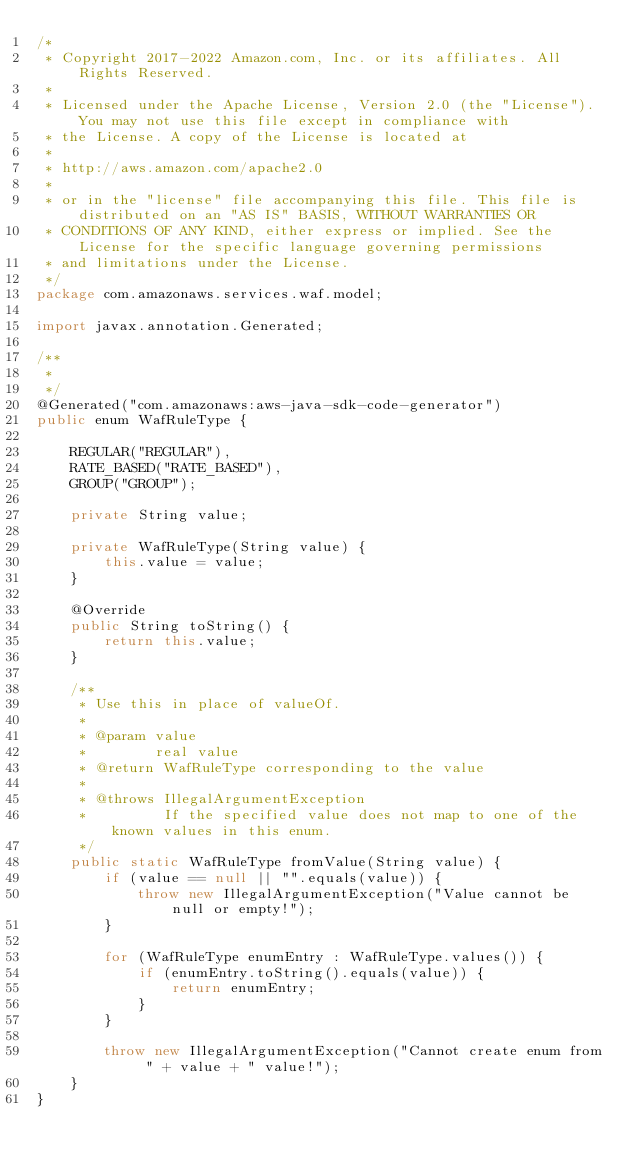Convert code to text. <code><loc_0><loc_0><loc_500><loc_500><_Java_>/*
 * Copyright 2017-2022 Amazon.com, Inc. or its affiliates. All Rights Reserved.
 * 
 * Licensed under the Apache License, Version 2.0 (the "License"). You may not use this file except in compliance with
 * the License. A copy of the License is located at
 * 
 * http://aws.amazon.com/apache2.0
 * 
 * or in the "license" file accompanying this file. This file is distributed on an "AS IS" BASIS, WITHOUT WARRANTIES OR
 * CONDITIONS OF ANY KIND, either express or implied. See the License for the specific language governing permissions
 * and limitations under the License.
 */
package com.amazonaws.services.waf.model;

import javax.annotation.Generated;

/**
 * 
 */
@Generated("com.amazonaws:aws-java-sdk-code-generator")
public enum WafRuleType {

    REGULAR("REGULAR"),
    RATE_BASED("RATE_BASED"),
    GROUP("GROUP");

    private String value;

    private WafRuleType(String value) {
        this.value = value;
    }

    @Override
    public String toString() {
        return this.value;
    }

    /**
     * Use this in place of valueOf.
     *
     * @param value
     *        real value
     * @return WafRuleType corresponding to the value
     *
     * @throws IllegalArgumentException
     *         If the specified value does not map to one of the known values in this enum.
     */
    public static WafRuleType fromValue(String value) {
        if (value == null || "".equals(value)) {
            throw new IllegalArgumentException("Value cannot be null or empty!");
        }

        for (WafRuleType enumEntry : WafRuleType.values()) {
            if (enumEntry.toString().equals(value)) {
                return enumEntry;
            }
        }

        throw new IllegalArgumentException("Cannot create enum from " + value + " value!");
    }
}
</code> 